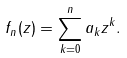<formula> <loc_0><loc_0><loc_500><loc_500>f _ { n } ( z ) = \sum _ { k = 0 } ^ { n } a _ { k } z ^ { k } .</formula> 